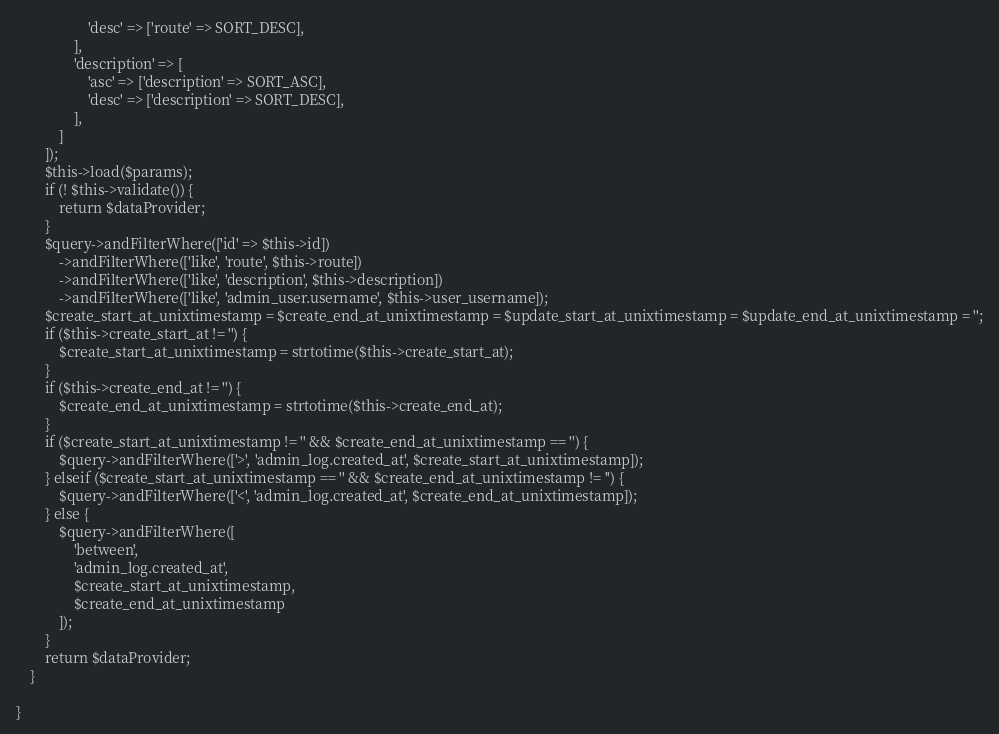<code> <loc_0><loc_0><loc_500><loc_500><_PHP_>                    'desc' => ['route' => SORT_DESC],
                ],
                'description' => [
                    'asc' => ['description' => SORT_ASC],
                    'desc' => ['description' => SORT_DESC],
                ],
            ]
        ]);
        $this->load($params);
        if (! $this->validate()) {
            return $dataProvider;
        }
        $query->andFilterWhere(['id' => $this->id])
            ->andFilterWhere(['like', 'route', $this->route])
            ->andFilterWhere(['like', 'description', $this->description])
            ->andFilterWhere(['like', 'admin_user.username', $this->user_username]);
        $create_start_at_unixtimestamp = $create_end_at_unixtimestamp = $update_start_at_unixtimestamp = $update_end_at_unixtimestamp = '';
        if ($this->create_start_at != '') {
            $create_start_at_unixtimestamp = strtotime($this->create_start_at);
        }
        if ($this->create_end_at != '') {
            $create_end_at_unixtimestamp = strtotime($this->create_end_at);
        }
        if ($create_start_at_unixtimestamp != '' && $create_end_at_unixtimestamp == '') {
            $query->andFilterWhere(['>', 'admin_log.created_at', $create_start_at_unixtimestamp]);
        } elseif ($create_start_at_unixtimestamp == '' && $create_end_at_unixtimestamp != '') {
            $query->andFilterWhere(['<', 'admin_log.created_at', $create_end_at_unixtimestamp]);
        } else {
            $query->andFilterWhere([
                'between',
                'admin_log.created_at',
                $create_start_at_unixtimestamp,
                $create_end_at_unixtimestamp
            ]);
        }
        return $dataProvider;
    }

}</code> 